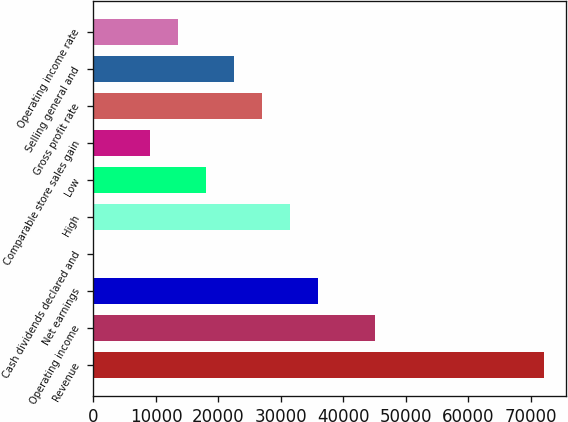Convert chart. <chart><loc_0><loc_0><loc_500><loc_500><bar_chart><fcel>Revenue<fcel>Operating income<fcel>Net earnings<fcel>Cash dividends declared and<fcel>High<fcel>Low<fcel>Comparable store sales gain<fcel>Gross profit rate<fcel>Selling general and<fcel>Operating income rate<nl><fcel>72023.7<fcel>45015<fcel>36012.1<fcel>0.54<fcel>31510.7<fcel>18006.3<fcel>9003.44<fcel>27009.2<fcel>22507.8<fcel>13504.9<nl></chart> 